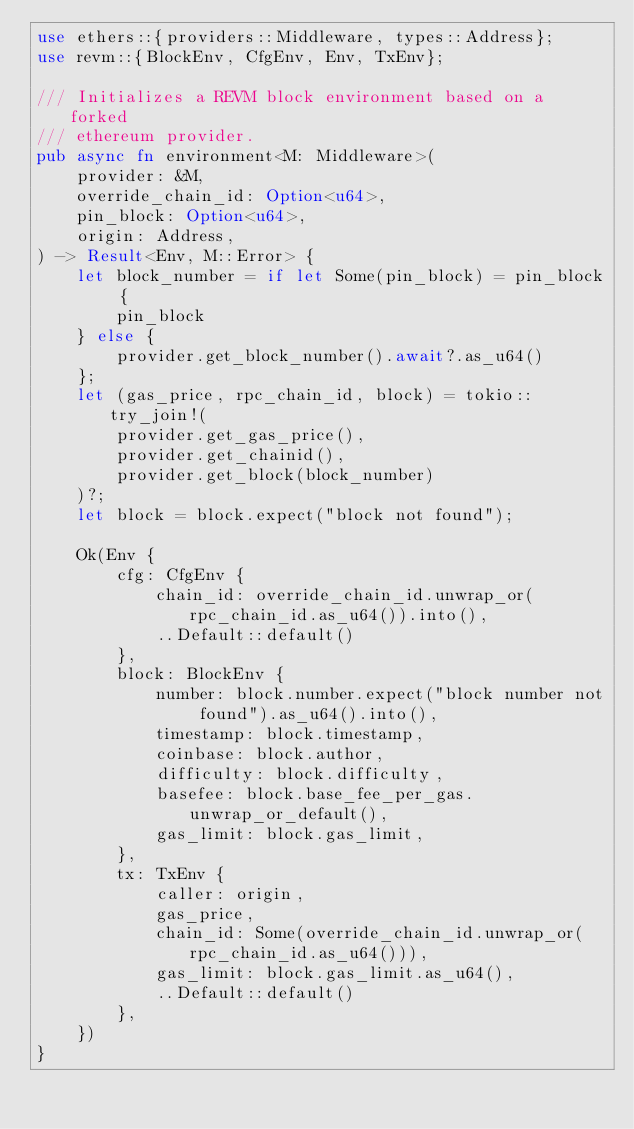Convert code to text. <code><loc_0><loc_0><loc_500><loc_500><_Rust_>use ethers::{providers::Middleware, types::Address};
use revm::{BlockEnv, CfgEnv, Env, TxEnv};

/// Initializes a REVM block environment based on a forked
/// ethereum provider.
pub async fn environment<M: Middleware>(
    provider: &M,
    override_chain_id: Option<u64>,
    pin_block: Option<u64>,
    origin: Address,
) -> Result<Env, M::Error> {
    let block_number = if let Some(pin_block) = pin_block {
        pin_block
    } else {
        provider.get_block_number().await?.as_u64()
    };
    let (gas_price, rpc_chain_id, block) = tokio::try_join!(
        provider.get_gas_price(),
        provider.get_chainid(),
        provider.get_block(block_number)
    )?;
    let block = block.expect("block not found");

    Ok(Env {
        cfg: CfgEnv {
            chain_id: override_chain_id.unwrap_or(rpc_chain_id.as_u64()).into(),
            ..Default::default()
        },
        block: BlockEnv {
            number: block.number.expect("block number not found").as_u64().into(),
            timestamp: block.timestamp,
            coinbase: block.author,
            difficulty: block.difficulty,
            basefee: block.base_fee_per_gas.unwrap_or_default(),
            gas_limit: block.gas_limit,
        },
        tx: TxEnv {
            caller: origin,
            gas_price,
            chain_id: Some(override_chain_id.unwrap_or(rpc_chain_id.as_u64())),
            gas_limit: block.gas_limit.as_u64(),
            ..Default::default()
        },
    })
}
</code> 